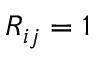Convert formula to latex. <formula><loc_0><loc_0><loc_500><loc_500>R _ { i j } = 1</formula> 